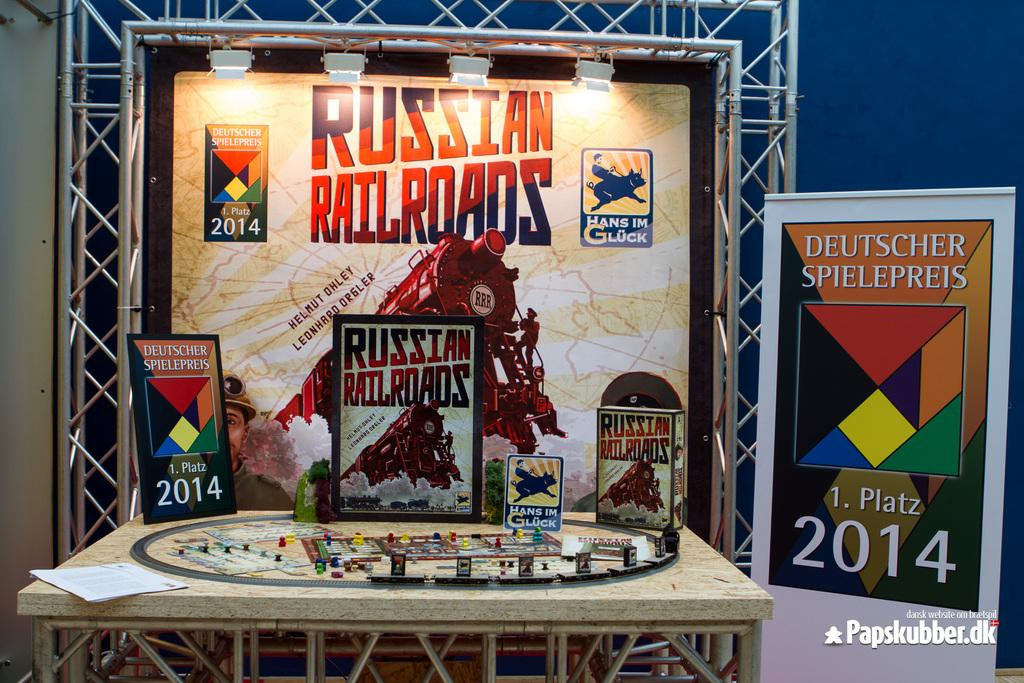Provide a one-sentence caption for the provided image. A Russian Railroads game is set up a a display table. 